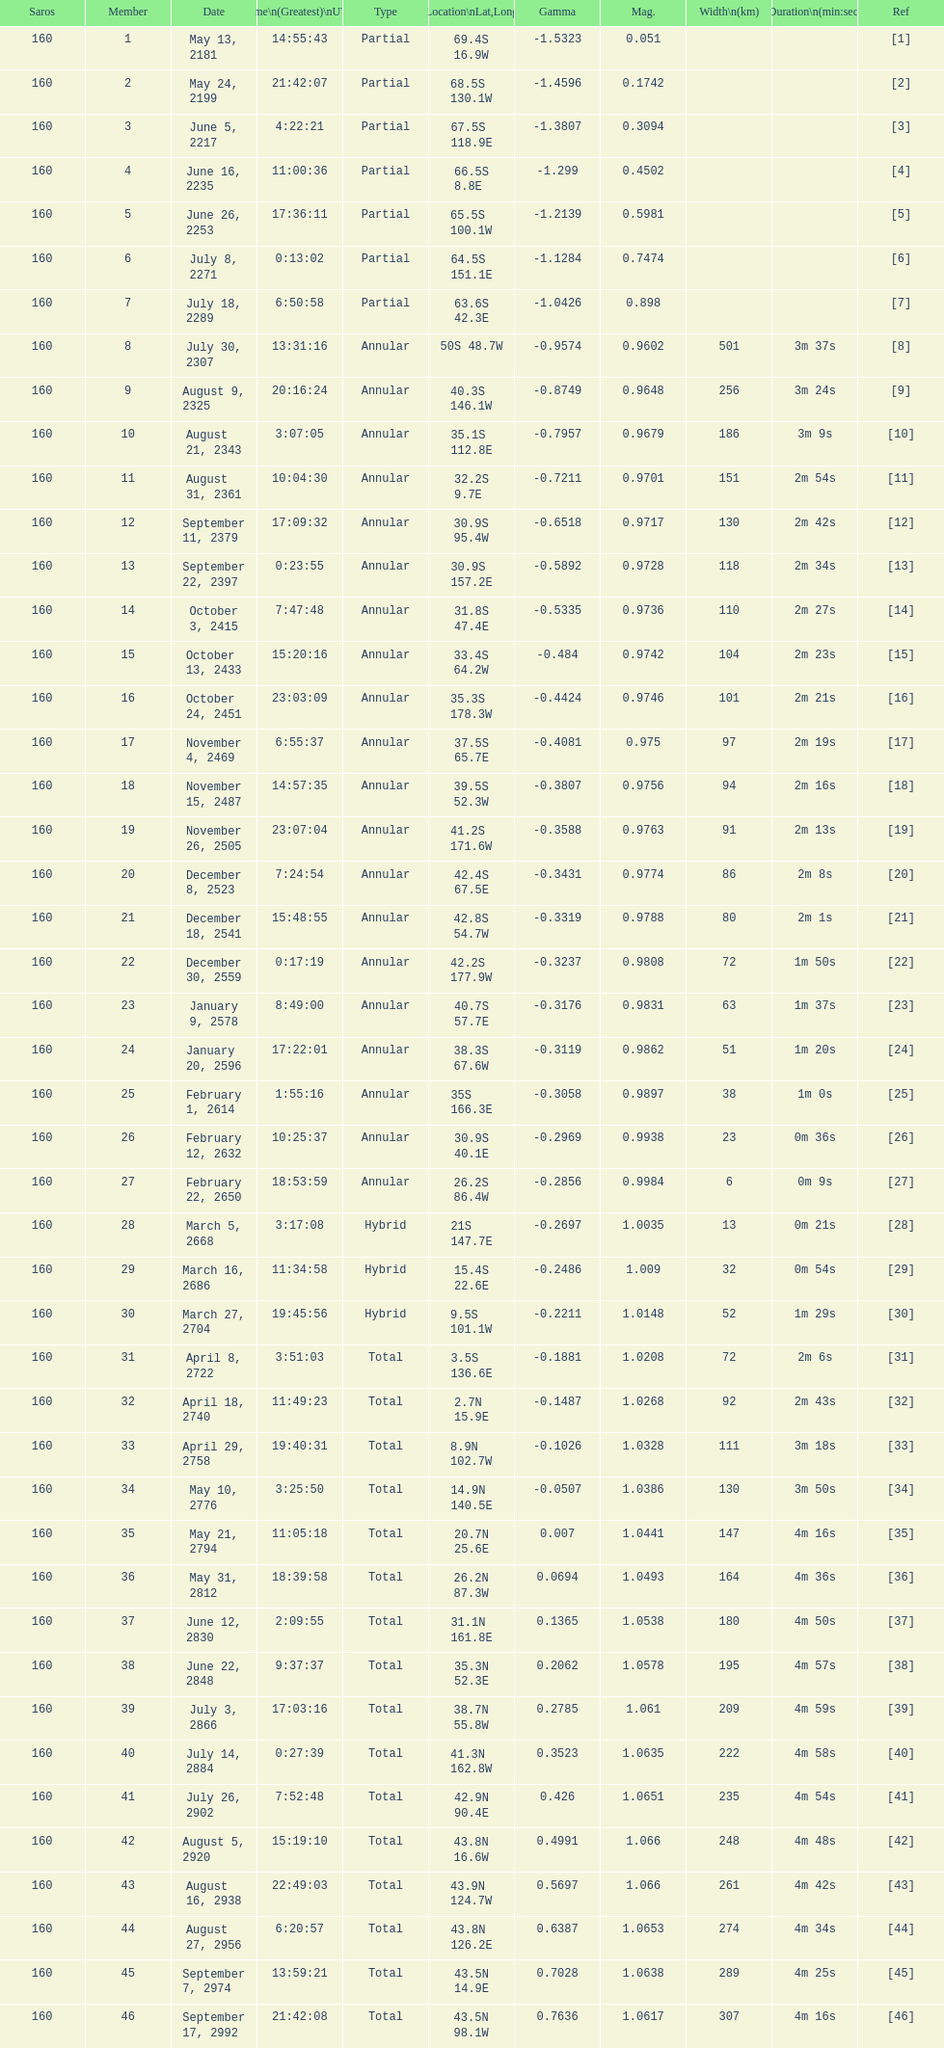What is the contrast in magnitude between the may 13, 2181 solar saros and the may 24, 2199 solar saros? 0.1232. 